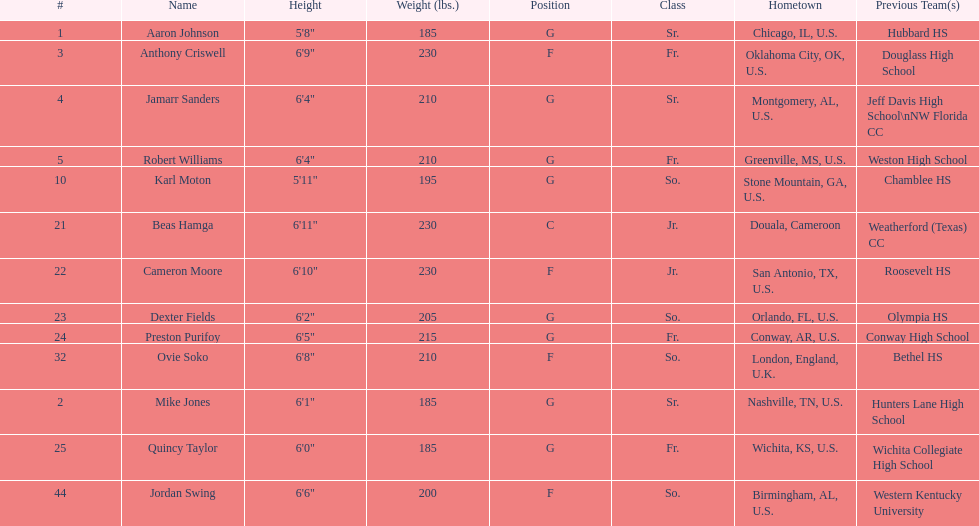How many players were on the 2010-11 uab blazers men's basketball team? 13. 